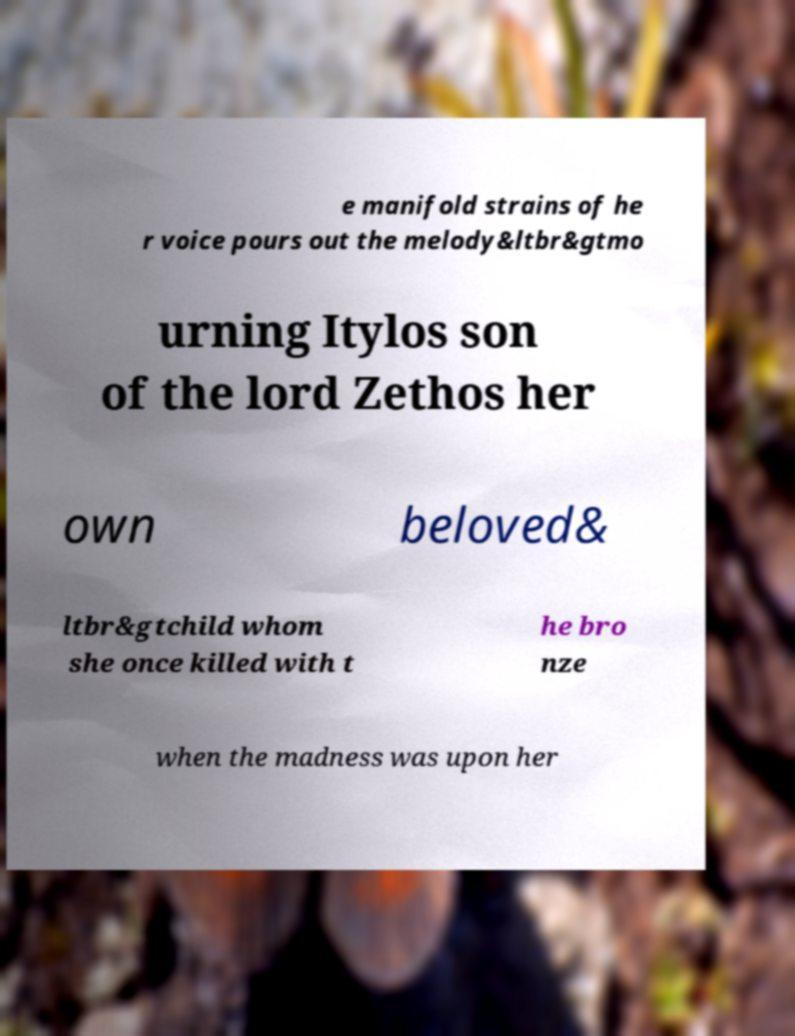Please read and relay the text visible in this image. What does it say? e manifold strains of he r voice pours out the melody&ltbr&gtmo urning Itylos son of the lord Zethos her own beloved& ltbr&gtchild whom she once killed with t he bro nze when the madness was upon her 